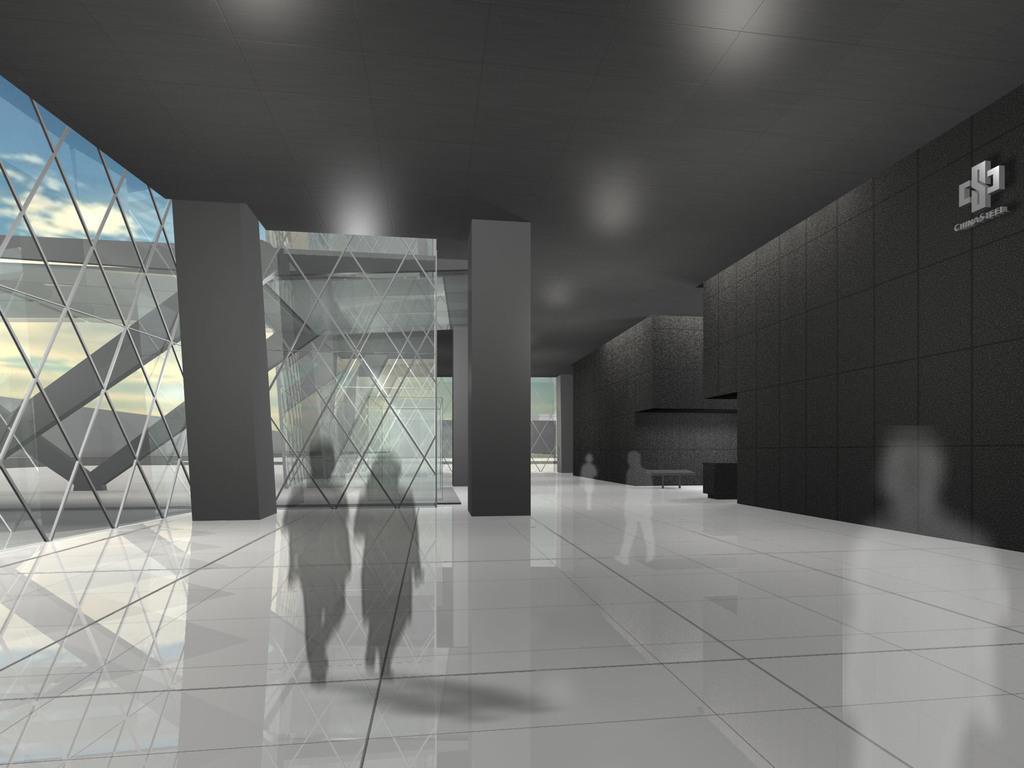How would you summarize this image in a sentence or two? In this image, we can see an inside view of a building. There are depiction of persons on the floor. There is a wall on the right side of the image. There are pillars in the middle of the image. There is a ceiling at the top of the image. 